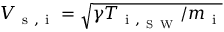Convert formula to latex. <formula><loc_0><loc_0><loc_500><loc_500>V _ { s , i } = \sqrt { \gamma T _ { i , _ { S W } } / m _ { i } }</formula> 